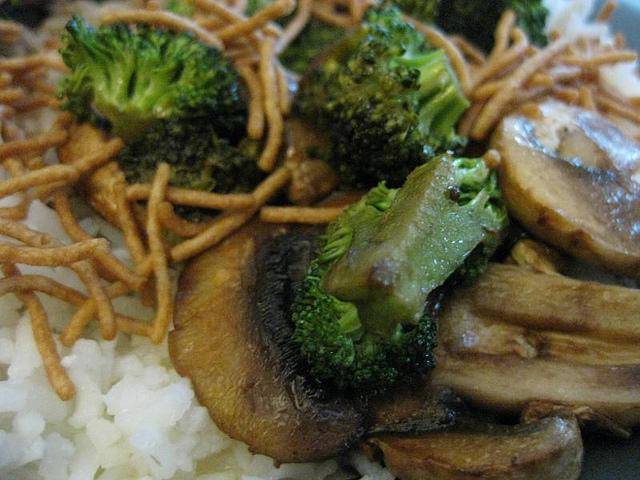What is the vegetable in this dish other than the broccoli?

Choices:
A) potatoes
B) carrots
C) onions
D) mushrooms mushrooms 